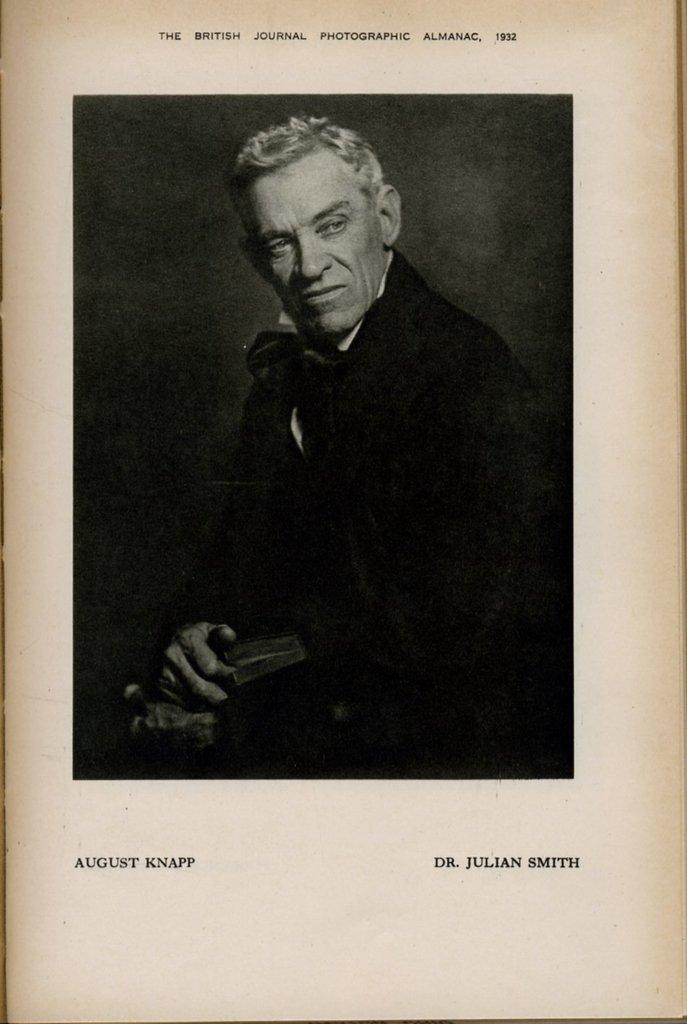What is present on the poster in the image? There is a poster in the image, and it has a person's image. What else can be seen on the poster besides the person's image? There is text written on the poster. What type of bird is talking to the person on the poster? There is no bird present on the poster, nor is there any indication of a conversation taking place. 